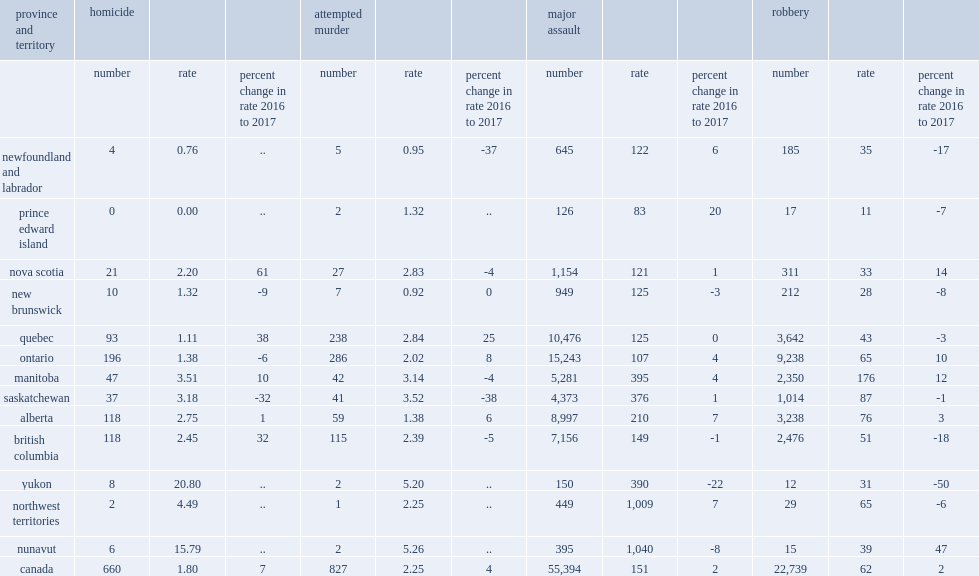Which province recorded the highest homicide rate among the provinces in 2017? Manitoba. 